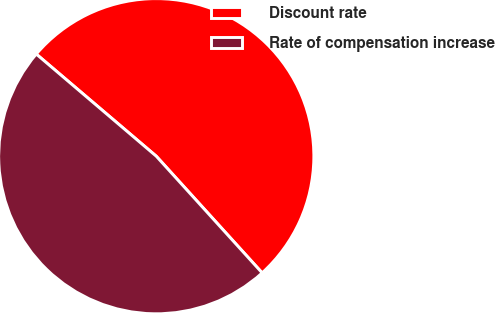Convert chart. <chart><loc_0><loc_0><loc_500><loc_500><pie_chart><fcel>Discount rate<fcel>Rate of compensation increase<nl><fcel>52.05%<fcel>47.95%<nl></chart> 